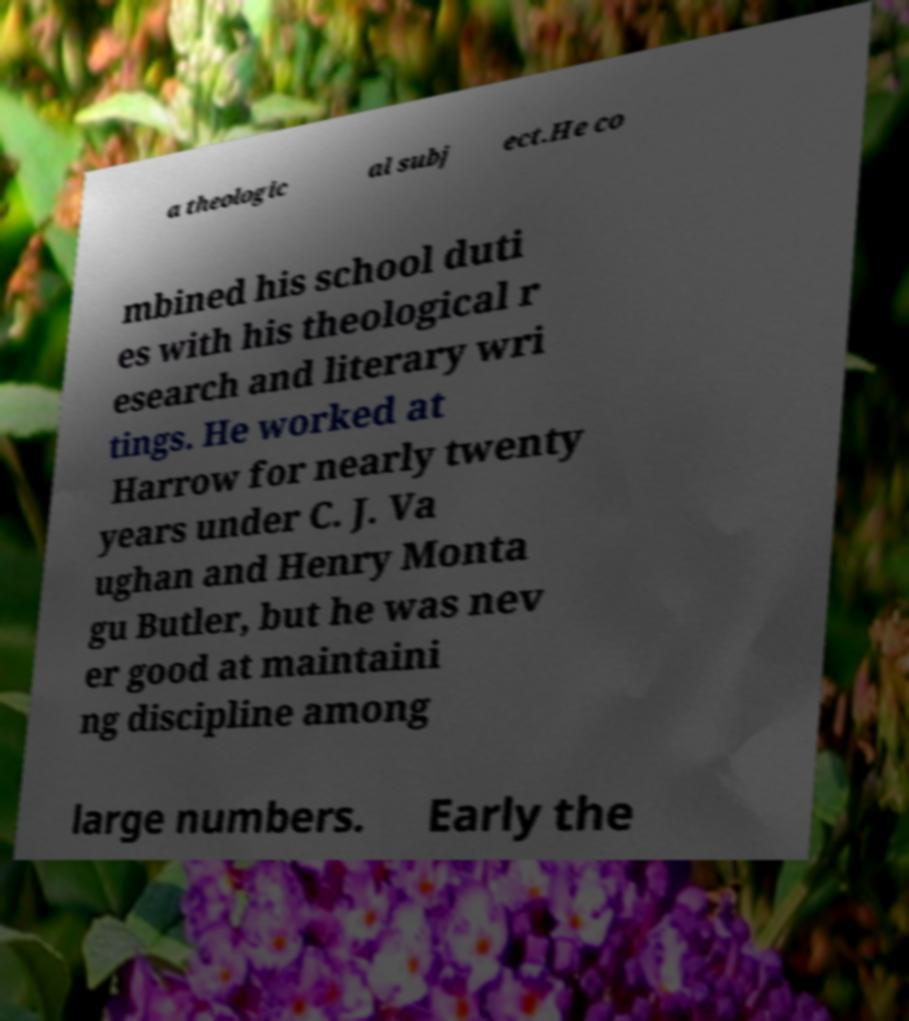Could you assist in decoding the text presented in this image and type it out clearly? a theologic al subj ect.He co mbined his school duti es with his theological r esearch and literary wri tings. He worked at Harrow for nearly twenty years under C. J. Va ughan and Henry Monta gu Butler, but he was nev er good at maintaini ng discipline among large numbers. Early the 